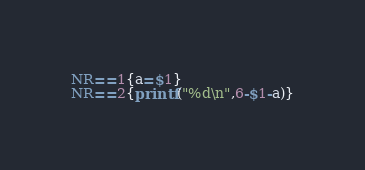<code> <loc_0><loc_0><loc_500><loc_500><_Awk_>NR==1{a=$1}
NR==2{printf("%d\n",6-$1-a)}</code> 